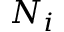<formula> <loc_0><loc_0><loc_500><loc_500>N _ { i }</formula> 